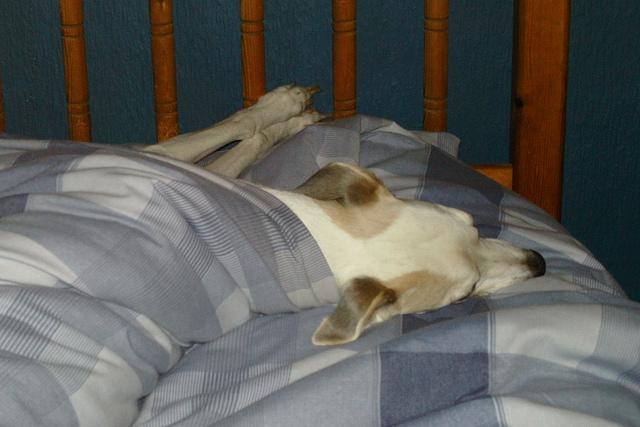Is this dog look like he's sleeping?
Quick response, please. Yes. What color is the blanket?
Write a very short answer. Blue. Where is the dog lying?
Write a very short answer. Bed. 